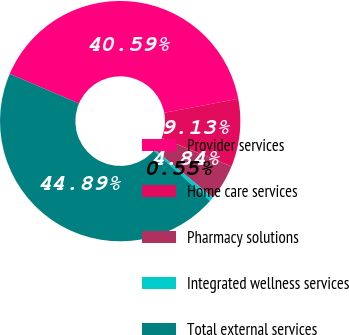Convert chart. <chart><loc_0><loc_0><loc_500><loc_500><pie_chart><fcel>Provider services<fcel>Home care services<fcel>Pharmacy solutions<fcel>Integrated wellness services<fcel>Total external services<nl><fcel>40.59%<fcel>9.13%<fcel>4.84%<fcel>0.55%<fcel>44.89%<nl></chart> 